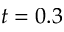<formula> <loc_0><loc_0><loc_500><loc_500>t = 0 . 3</formula> 